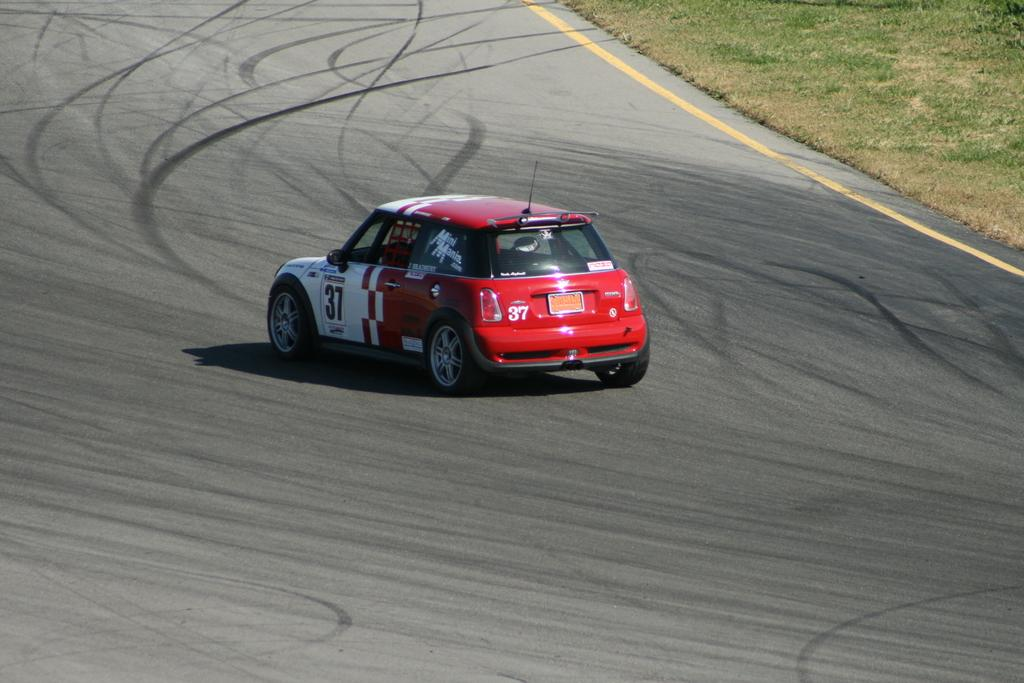What is the main subject of the picture? The main subject of the picture is a car. Where is the car located in the image? The car is on the road in the middle of the picture. What can be seen on the side of the road? There is green grass visible on the side of the road. Where is the green grass located in the image? The green grass is on the top right side of the image. What camp songs can be heard playing from the car in the image? There is no indication in the image that any camp songs are playing from the car, as there is no mention of audio or any related context. 